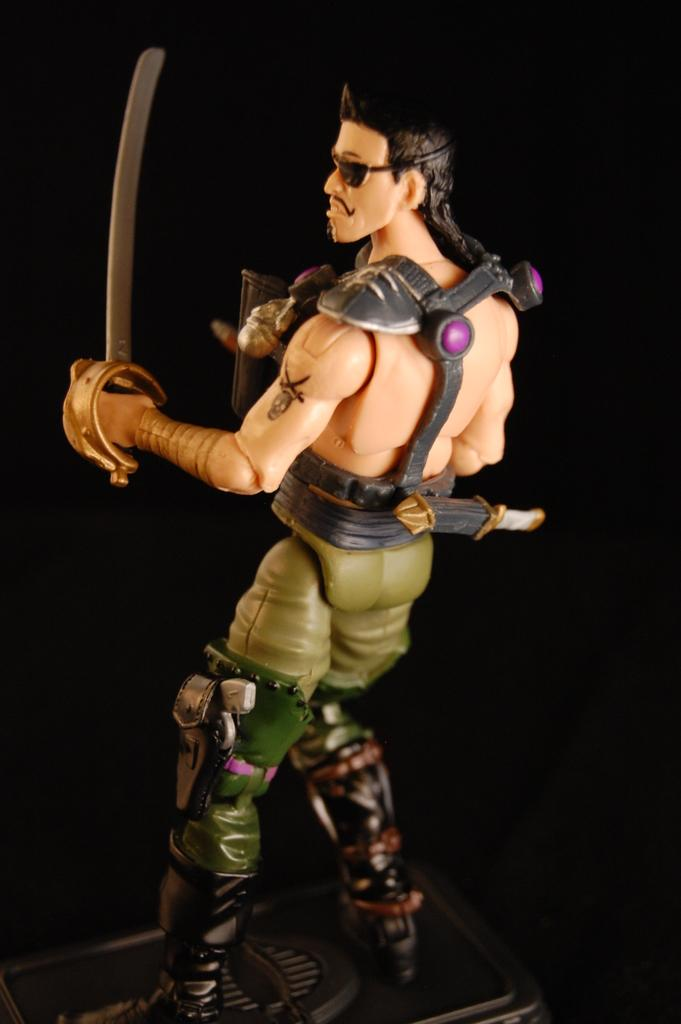What type of object is in the image? There is a toy of a person in the image. What is the toy person holding? The toy person is holding a sword. What can be observed about the background of the image? The background of the image is dark. What type of bait is the toy person using to catch fish in the image? There is no bait or fishing activity depicted in the image; the toy person is holding a sword. 